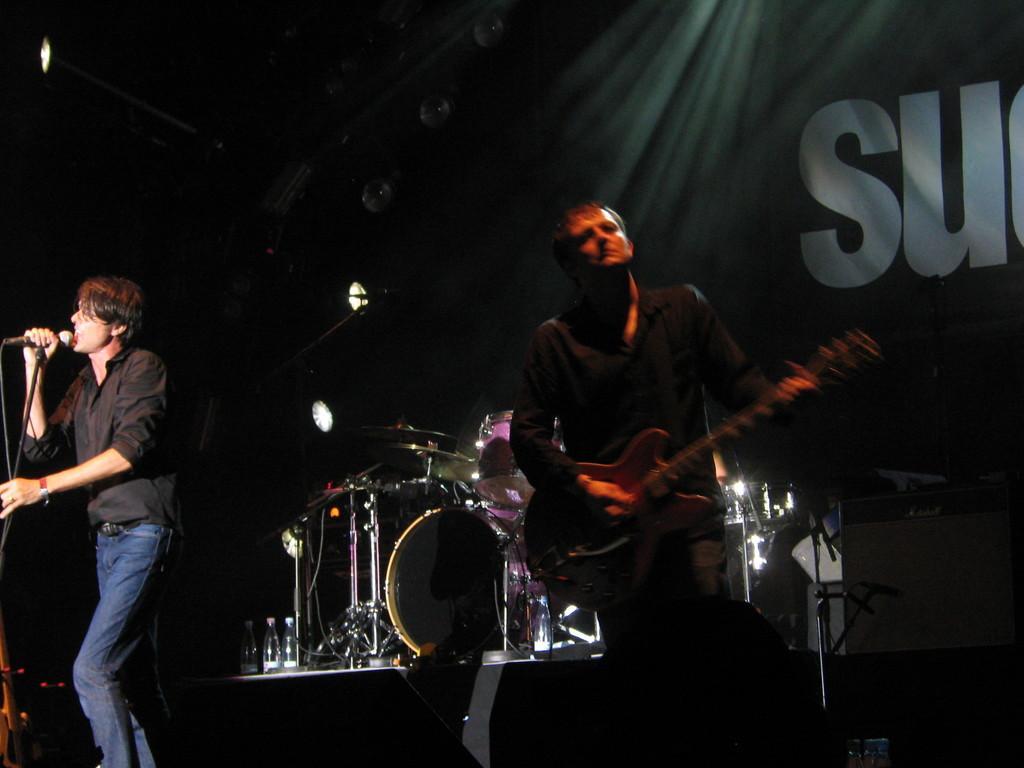Can you describe this image briefly? As we can see in the image there is a cloth and two people standing over here. The man who is standing on the left side is holding mic and singing a song and the man on the right side is holding guitar and in the middle there are musical drums. 